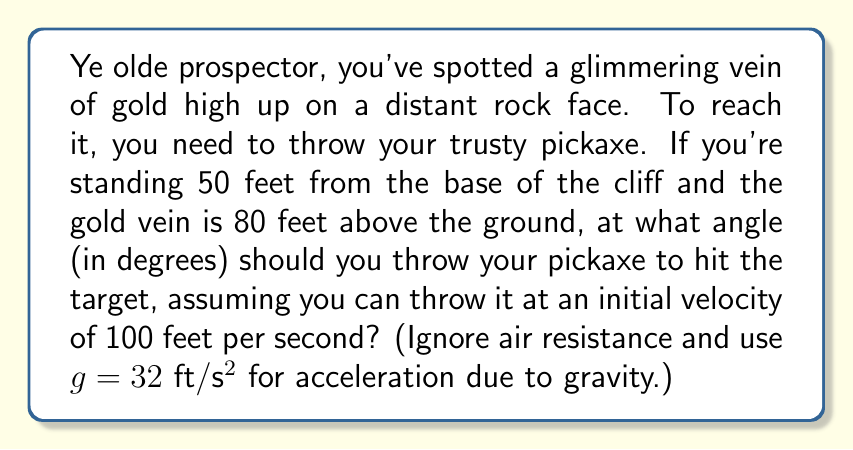Give your solution to this math problem. Let's approach this step-by-step, using the equations of projectile motion:

1) First, we need to set up our coordinate system. Let's use the horizontal distance as x and the vertical distance as y.

2) The equation for the trajectory of a projectile is:

   $$y = x \tan(\theta) - \frac{gx^2}{2v_0^2\cos^2(\theta)}$$

   Where $\theta$ is the angle of launch, $v_0$ is the initial velocity, and $g$ is acceleration due to gravity.

3) We know that when $x = 50$ (feet), $y = 80$ (feet). We can substitute these values:

   $$80 = 50 \tan(\theta) - \frac{32 \cdot 50^2}{2 \cdot 100^2\cos^2(\theta)}$$

4) Simplify:

   $$80 = 50 \tan(\theta) - \frac{40000}{20000\cos^2(\theta)} = 50 \tan(\theta) - \frac{2}{\cos^2(\theta)}$$

5) Multiply both sides by $\cos^2(\theta)$:

   $$80\cos^2(\theta) = 50\sin(\theta)\cos(\theta) - 2$$

6) Use the identity $\sin(2\theta) = 2\sin(\theta)\cos(\theta)$:

   $$80\cos^2(\theta) = 25\sin(2\theta) - 2$$

7) This equation can't be solved algebraically. We need to use numerical methods or a graphing calculator to find $\theta$.

8) Using a numerical solver, we find that $\theta \approx 60.64°$.
Answer: $60.64°$ 